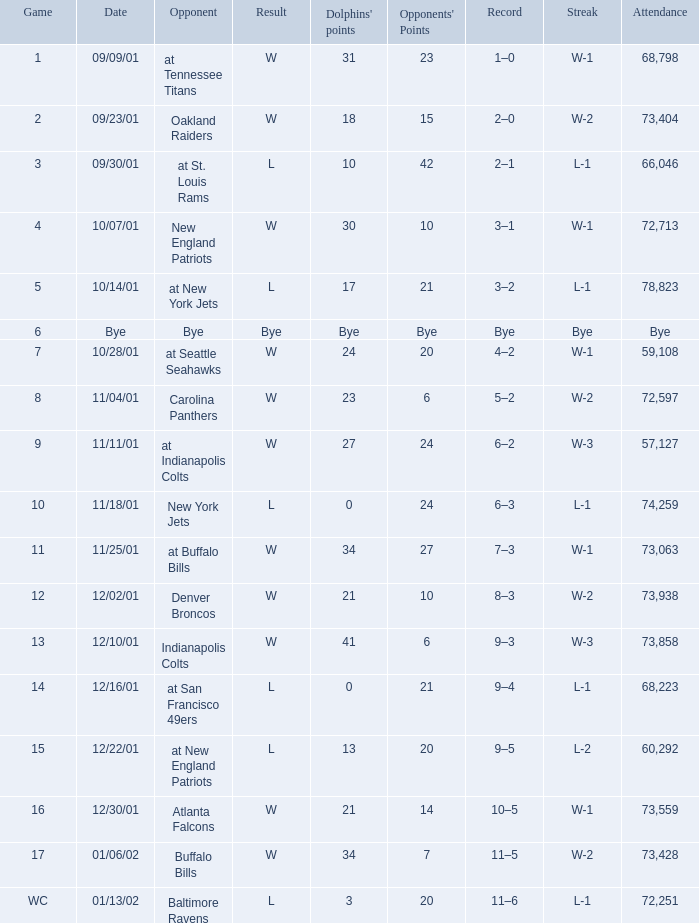How many rival points were there on 11/11/01? 24.0. 